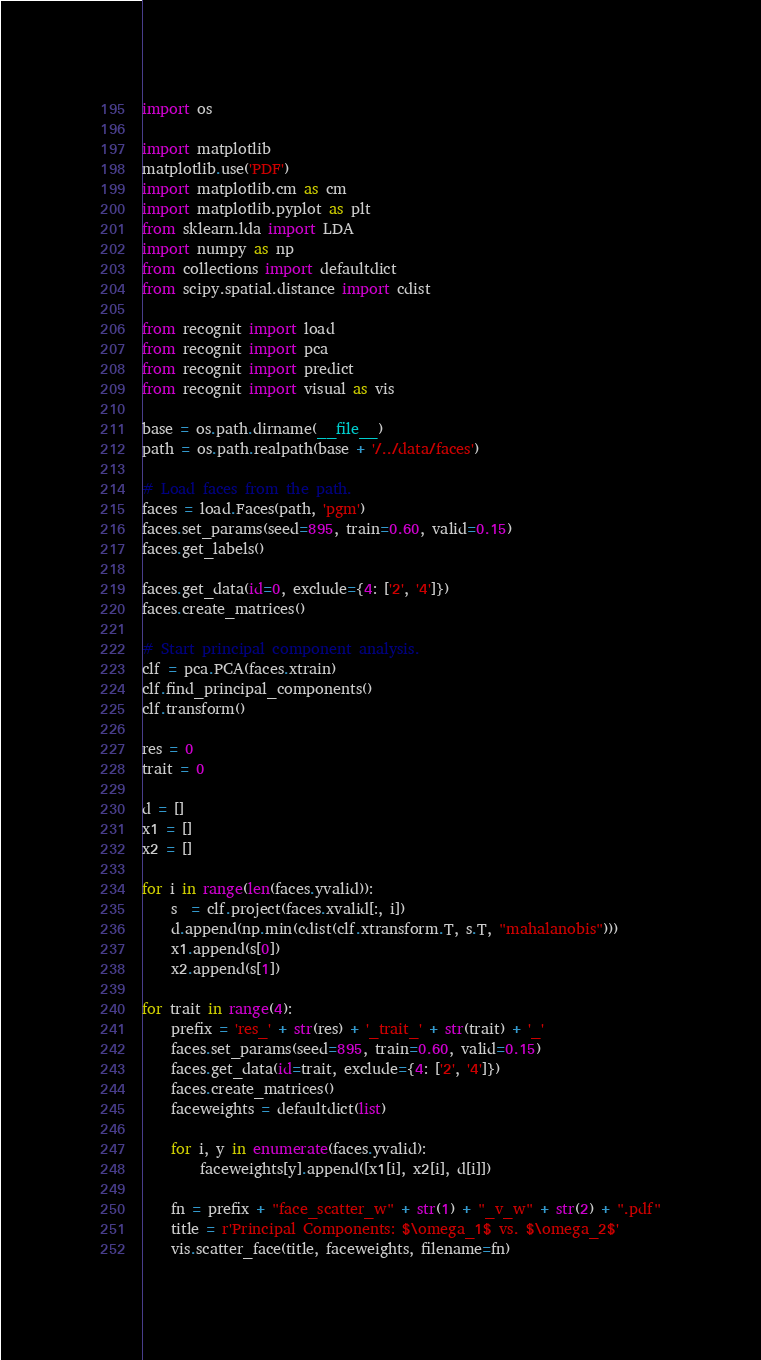Convert code to text. <code><loc_0><loc_0><loc_500><loc_500><_Python_>import os

import matplotlib
matplotlib.use('PDF')
import matplotlib.cm as cm
import matplotlib.pyplot as plt
from sklearn.lda import LDA
import numpy as np
from collections import defaultdict
from scipy.spatial.distance import cdist

from recognit import load
from recognit import pca
from recognit import predict
from recognit import visual as vis

base = os.path.dirname(__file__)
path = os.path.realpath(base + '/../data/faces')

# Load faces from the path.
faces = load.Faces(path, 'pgm')
faces.set_params(seed=895, train=0.60, valid=0.15)
faces.get_labels()

faces.get_data(id=0, exclude={4: ['2', '4']})
faces.create_matrices()

# Start principal component analysis.
clf = pca.PCA(faces.xtrain)
clf.find_principal_components()
clf.transform()

res = 0
trait = 0

d = []
x1 = []
x2 = []

for i in range(len(faces.yvalid)):
	s  = clf.project(faces.xvalid[:, i])
	d.append(np.min(cdist(clf.xtransform.T, s.T, "mahalanobis")))
	x1.append(s[0])
	x2.append(s[1])

for trait in range(4):
	prefix = 'res_' + str(res) + '_trait_' + str(trait) + '_'
	faces.set_params(seed=895, train=0.60, valid=0.15)
	faces.get_data(id=trait, exclude={4: ['2', '4']})
	faces.create_matrices()
	faceweights = defaultdict(list)
	
	for i, y in enumerate(faces.yvalid):
		faceweights[y].append([x1[i], x2[i], d[i]])

	fn = prefix + "face_scatter_w" + str(1) + "_v_w" + str(2) + ".pdf"
	title = r'Principal Components: $\omega_1$ vs. $\omega_2$'
	vis.scatter_face(title, faceweights, filename=fn)

</code> 